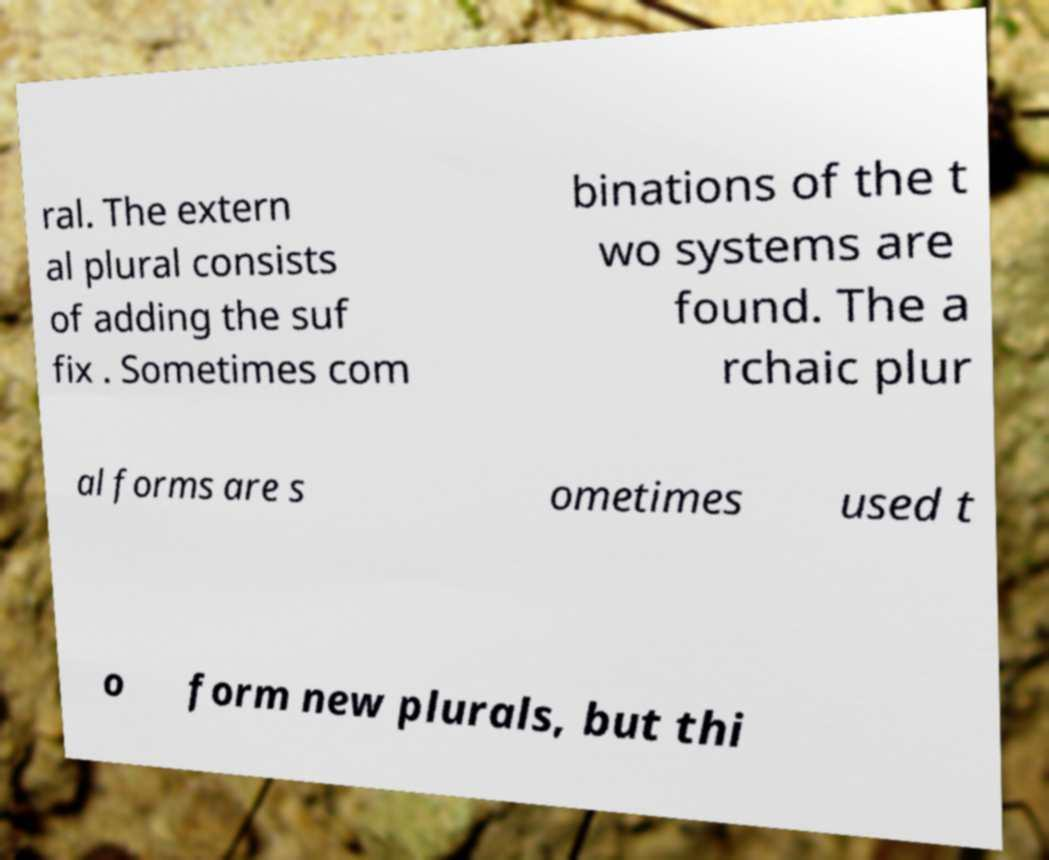Can you read and provide the text displayed in the image?This photo seems to have some interesting text. Can you extract and type it out for me? ral. The extern al plural consists of adding the suf fix . Sometimes com binations of the t wo systems are found. The a rchaic plur al forms are s ometimes used t o form new plurals, but thi 